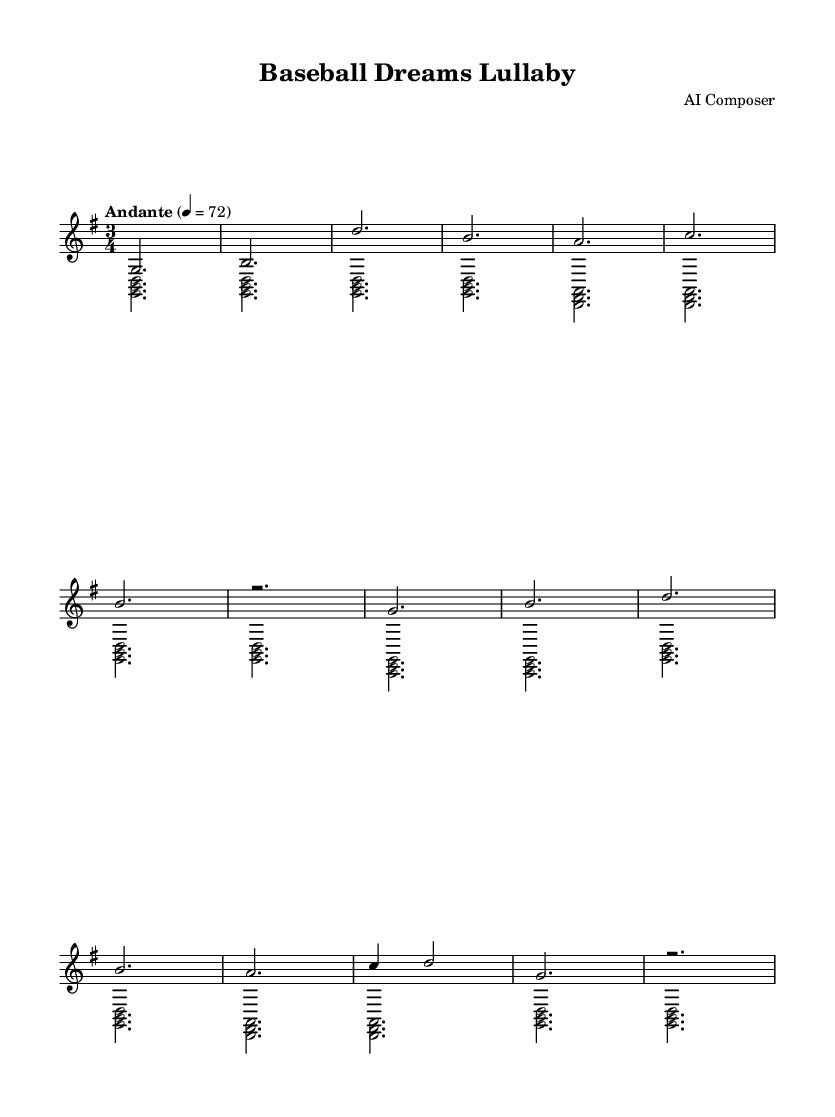What is the key signature of this music? The key signature shows one sharp, which indicates that the piece is in G major. G major has an F sharp.
Answer: G major What is the time signature of this piece? The time signature is 3/4, meaning there are three beats in each measure and the quarter note gets one beat.
Answer: 3/4 What is the tempo marking for this composition? The tempo marking indicates "Andante" at the speed of 72 beats per minute, suggesting a moderate pace for the music.
Answer: Andante How many measures are in the melody? By counting the groups of notes in the melody section, there are a total of 14 measures.
Answer: 14 What is the first note of the melody? The melody begins with the note G, which is indicated as the first note in the score.
Answer: G What is the type of chord used in the harmony? The harmony section shows several triads, specifically major chords like G major, D major, and C major, which are common in classical compositions.
Answer: Major chords How many voices are in the score? There are two voices in the score: the melody and the harmony, which are separated within the piano staff.
Answer: Two 